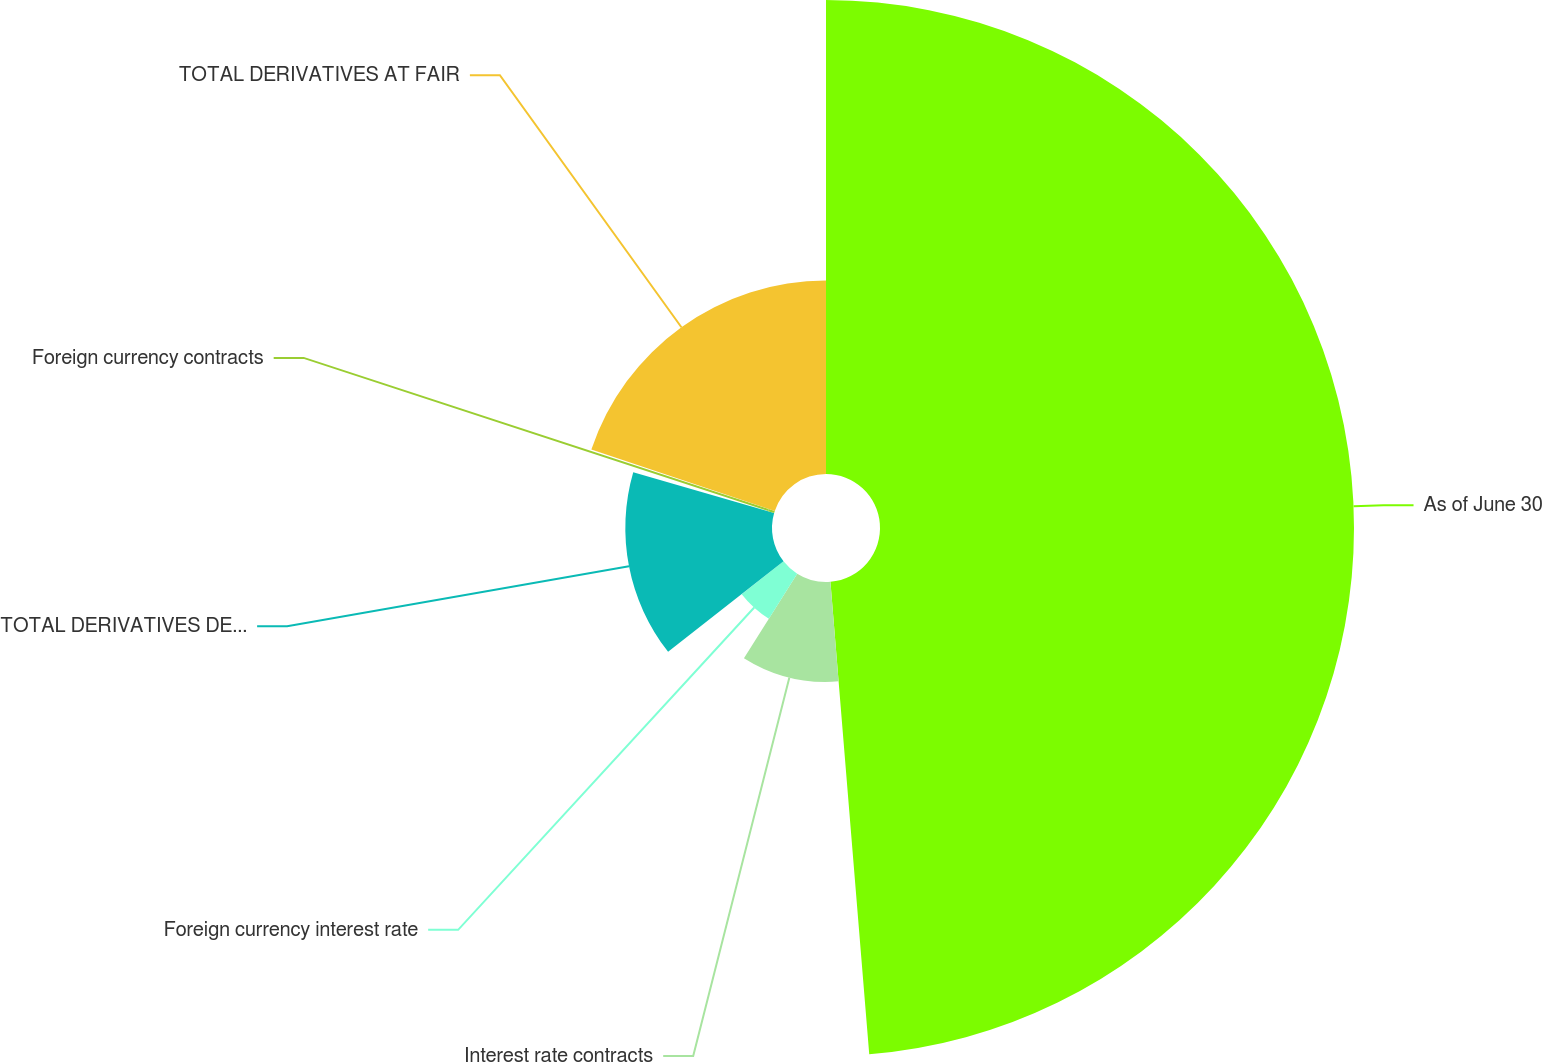<chart> <loc_0><loc_0><loc_500><loc_500><pie_chart><fcel>As of June 30<fcel>Interest rate contracts<fcel>Foreign currency interest rate<fcel>TOTAL DERIVATIVES DESIGNATED<fcel>Foreign currency contracts<fcel>TOTAL DERIVATIVES AT FAIR<nl><fcel>48.7%<fcel>10.26%<fcel>5.46%<fcel>15.07%<fcel>0.65%<fcel>19.87%<nl></chart> 